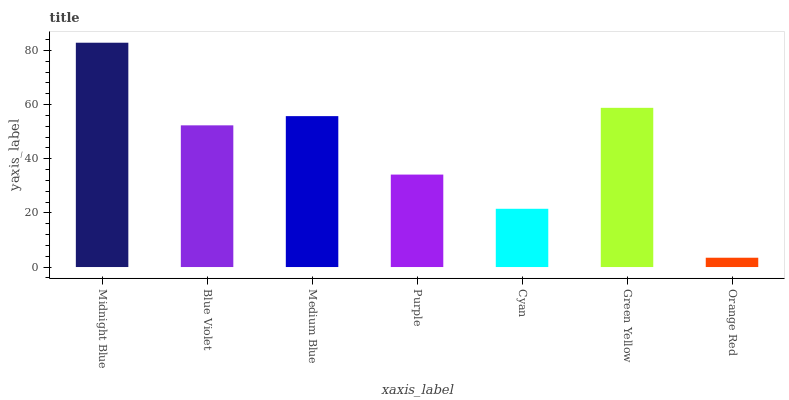Is Orange Red the minimum?
Answer yes or no. Yes. Is Midnight Blue the maximum?
Answer yes or no. Yes. Is Blue Violet the minimum?
Answer yes or no. No. Is Blue Violet the maximum?
Answer yes or no. No. Is Midnight Blue greater than Blue Violet?
Answer yes or no. Yes. Is Blue Violet less than Midnight Blue?
Answer yes or no. Yes. Is Blue Violet greater than Midnight Blue?
Answer yes or no. No. Is Midnight Blue less than Blue Violet?
Answer yes or no. No. Is Blue Violet the high median?
Answer yes or no. Yes. Is Blue Violet the low median?
Answer yes or no. Yes. Is Purple the high median?
Answer yes or no. No. Is Green Yellow the low median?
Answer yes or no. No. 